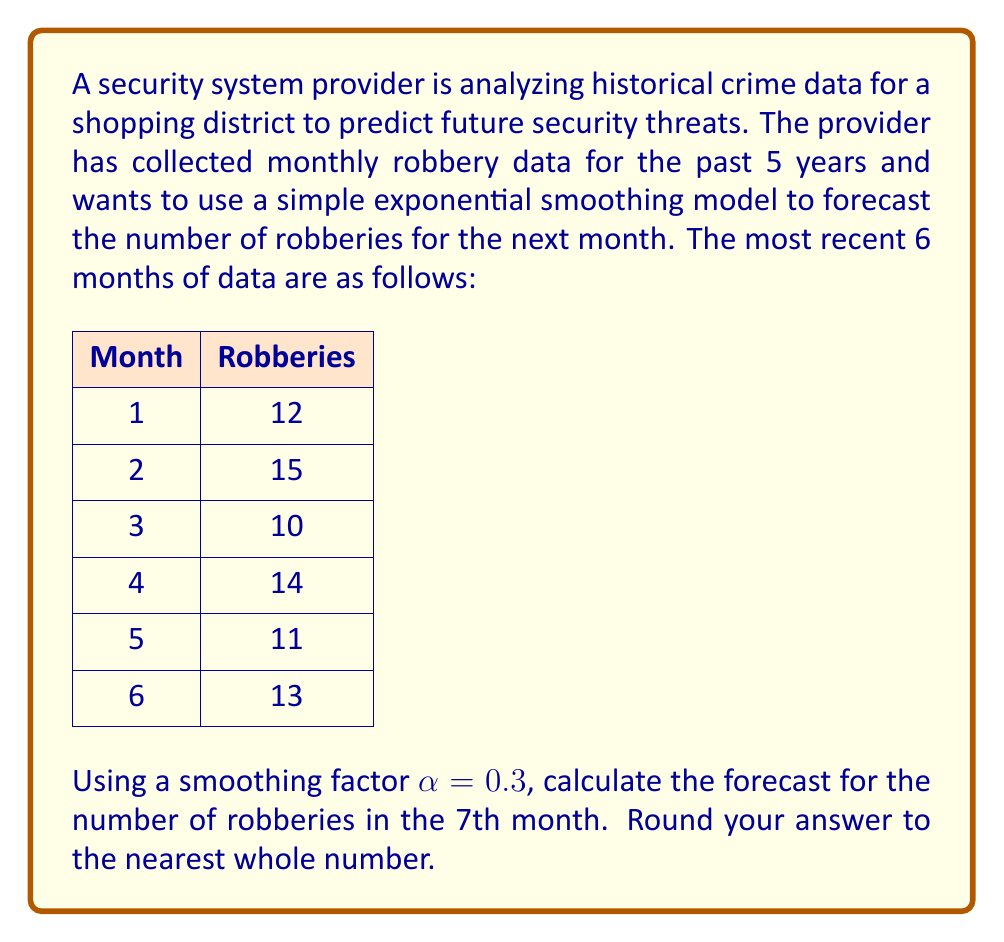Help me with this question. To solve this problem, we'll use the simple exponential smoothing model, which is given by the formula:

$$F_{t+1} = \alpha Y_t + (1-\alpha)F_t$$

Where:
$F_{t+1}$ is the forecast for the next period
$\alpha$ is the smoothing factor (0.3 in this case)
$Y_t$ is the actual value for the current period
$F_t$ is the forecast for the current period

We'll start by calculating the forecast for each month, beginning with month 2:

1. For month 2:
   $F_2 = \alpha Y_1 + (1-\alpha)F_1$
   We don't have a previous forecast, so we'll use the first actual value as our initial forecast.
   $F_2 = 0.3(12) + 0.7(12) = 12$

2. For month 3:
   $F_3 = 0.3(15) + 0.7(12) = 12.9$

3. For month 4:
   $F_4 = 0.3(10) + 0.7(12.9) = 12.03$

4. For month 5:
   $F_5 = 0.3(14) + 0.7(12.03) = 12.621$

5. For month 6:
   $F_6 = 0.3(11) + 0.7(12.621) = 12.1347$

6. For month 7 (our target forecast):
   $F_7 = 0.3(13) + 0.7(12.1347) = 12.39429$

Rounding to the nearest whole number, we get 12.
Answer: 12 robberies 